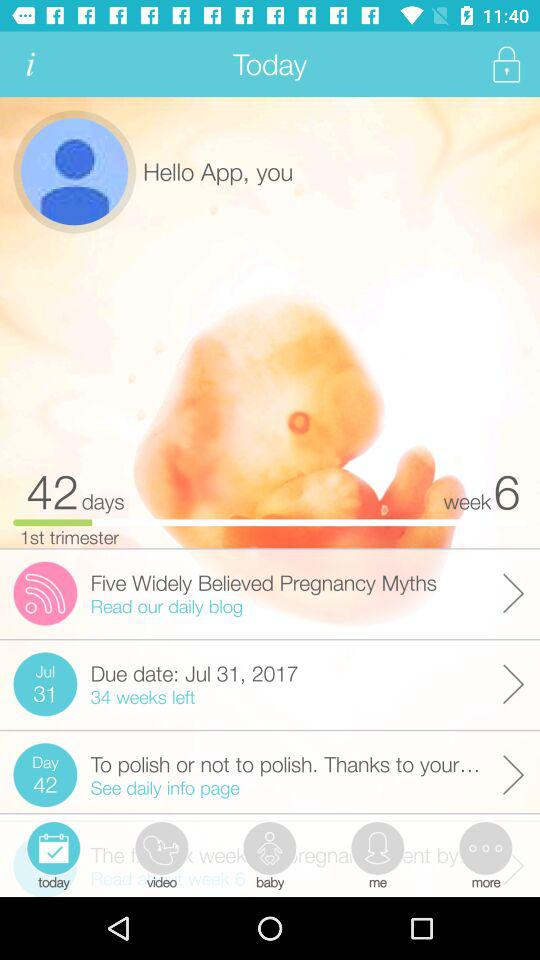How many weeks are left until the due date?
Answer the question using a single word or phrase. 34 